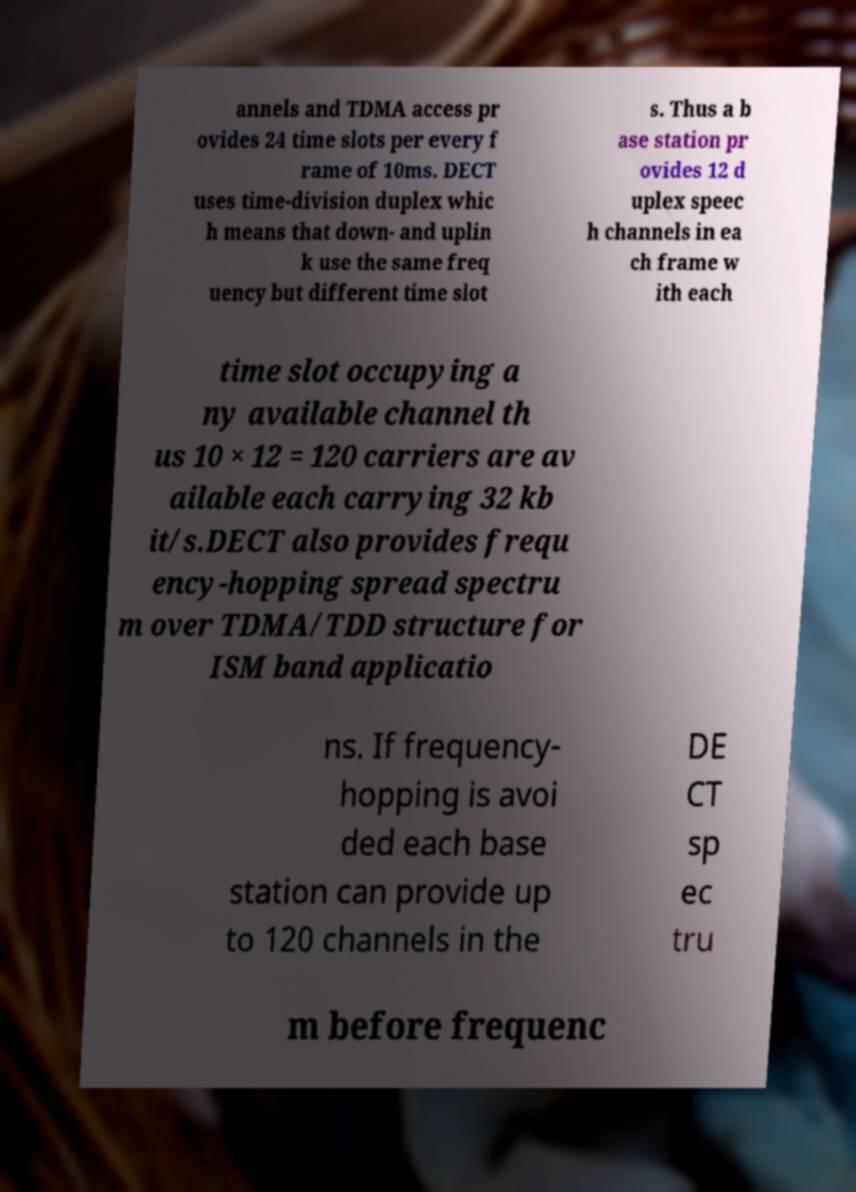There's text embedded in this image that I need extracted. Can you transcribe it verbatim? annels and TDMA access pr ovides 24 time slots per every f rame of 10ms. DECT uses time-division duplex whic h means that down- and uplin k use the same freq uency but different time slot s. Thus a b ase station pr ovides 12 d uplex speec h channels in ea ch frame w ith each time slot occupying a ny available channel th us 10 × 12 = 120 carriers are av ailable each carrying 32 kb it/s.DECT also provides frequ ency-hopping spread spectru m over TDMA/TDD structure for ISM band applicatio ns. If frequency- hopping is avoi ded each base station can provide up to 120 channels in the DE CT sp ec tru m before frequenc 